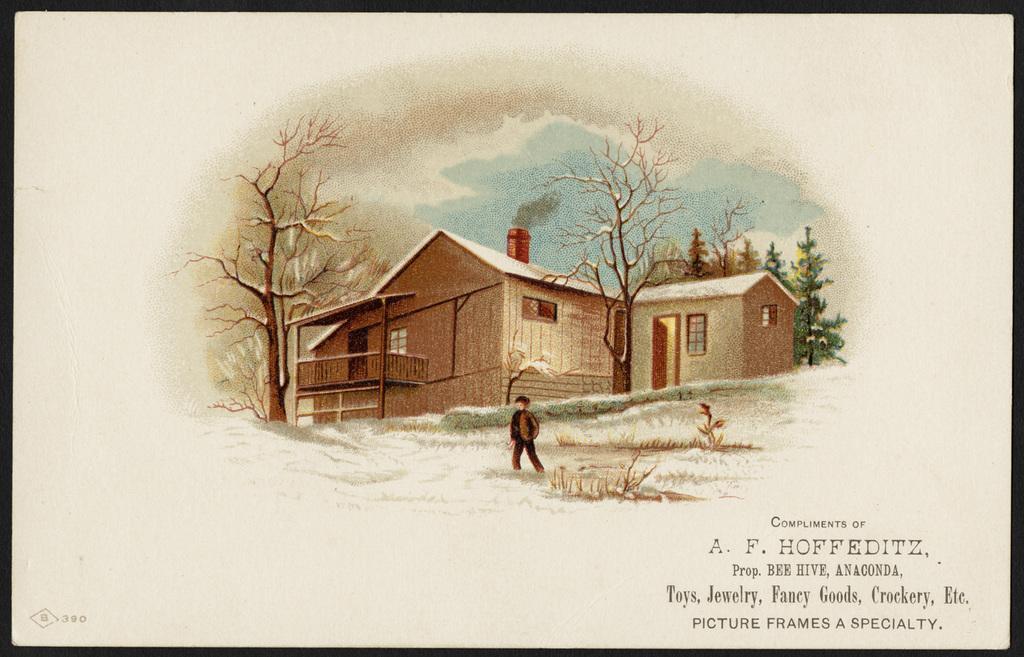How would you summarize this image in a sentence or two? This image contains a painting. A person is standing on the grassland. Behind him there are few trees and buildings. Top of it there is sky. Right bottom there is some text. 